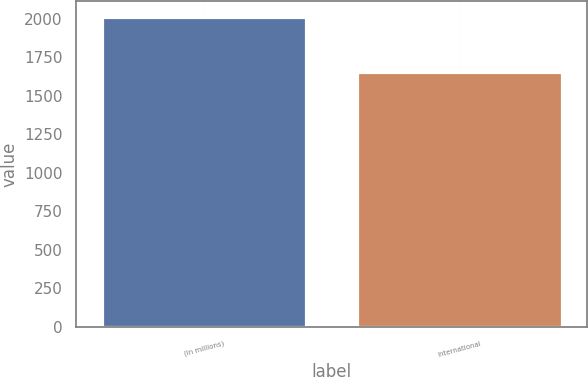Convert chart to OTSL. <chart><loc_0><loc_0><loc_500><loc_500><bar_chart><fcel>(In millions)<fcel>International<nl><fcel>2012<fcel>1651<nl></chart> 